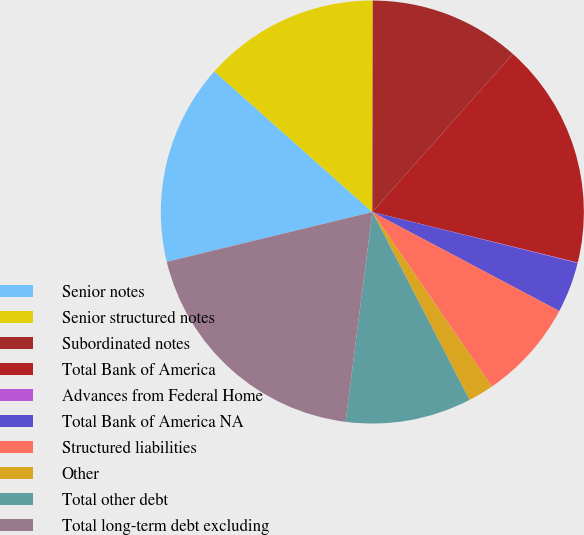Convert chart to OTSL. <chart><loc_0><loc_0><loc_500><loc_500><pie_chart><fcel>Senior notes<fcel>Senior structured notes<fcel>Subordinated notes<fcel>Total Bank of America<fcel>Advances from Federal Home<fcel>Total Bank of America NA<fcel>Structured liabilities<fcel>Other<fcel>Total other debt<fcel>Total long-term debt excluding<nl><fcel>15.36%<fcel>13.45%<fcel>11.53%<fcel>17.28%<fcel>0.04%<fcel>3.87%<fcel>7.7%<fcel>1.95%<fcel>9.62%<fcel>19.2%<nl></chart> 